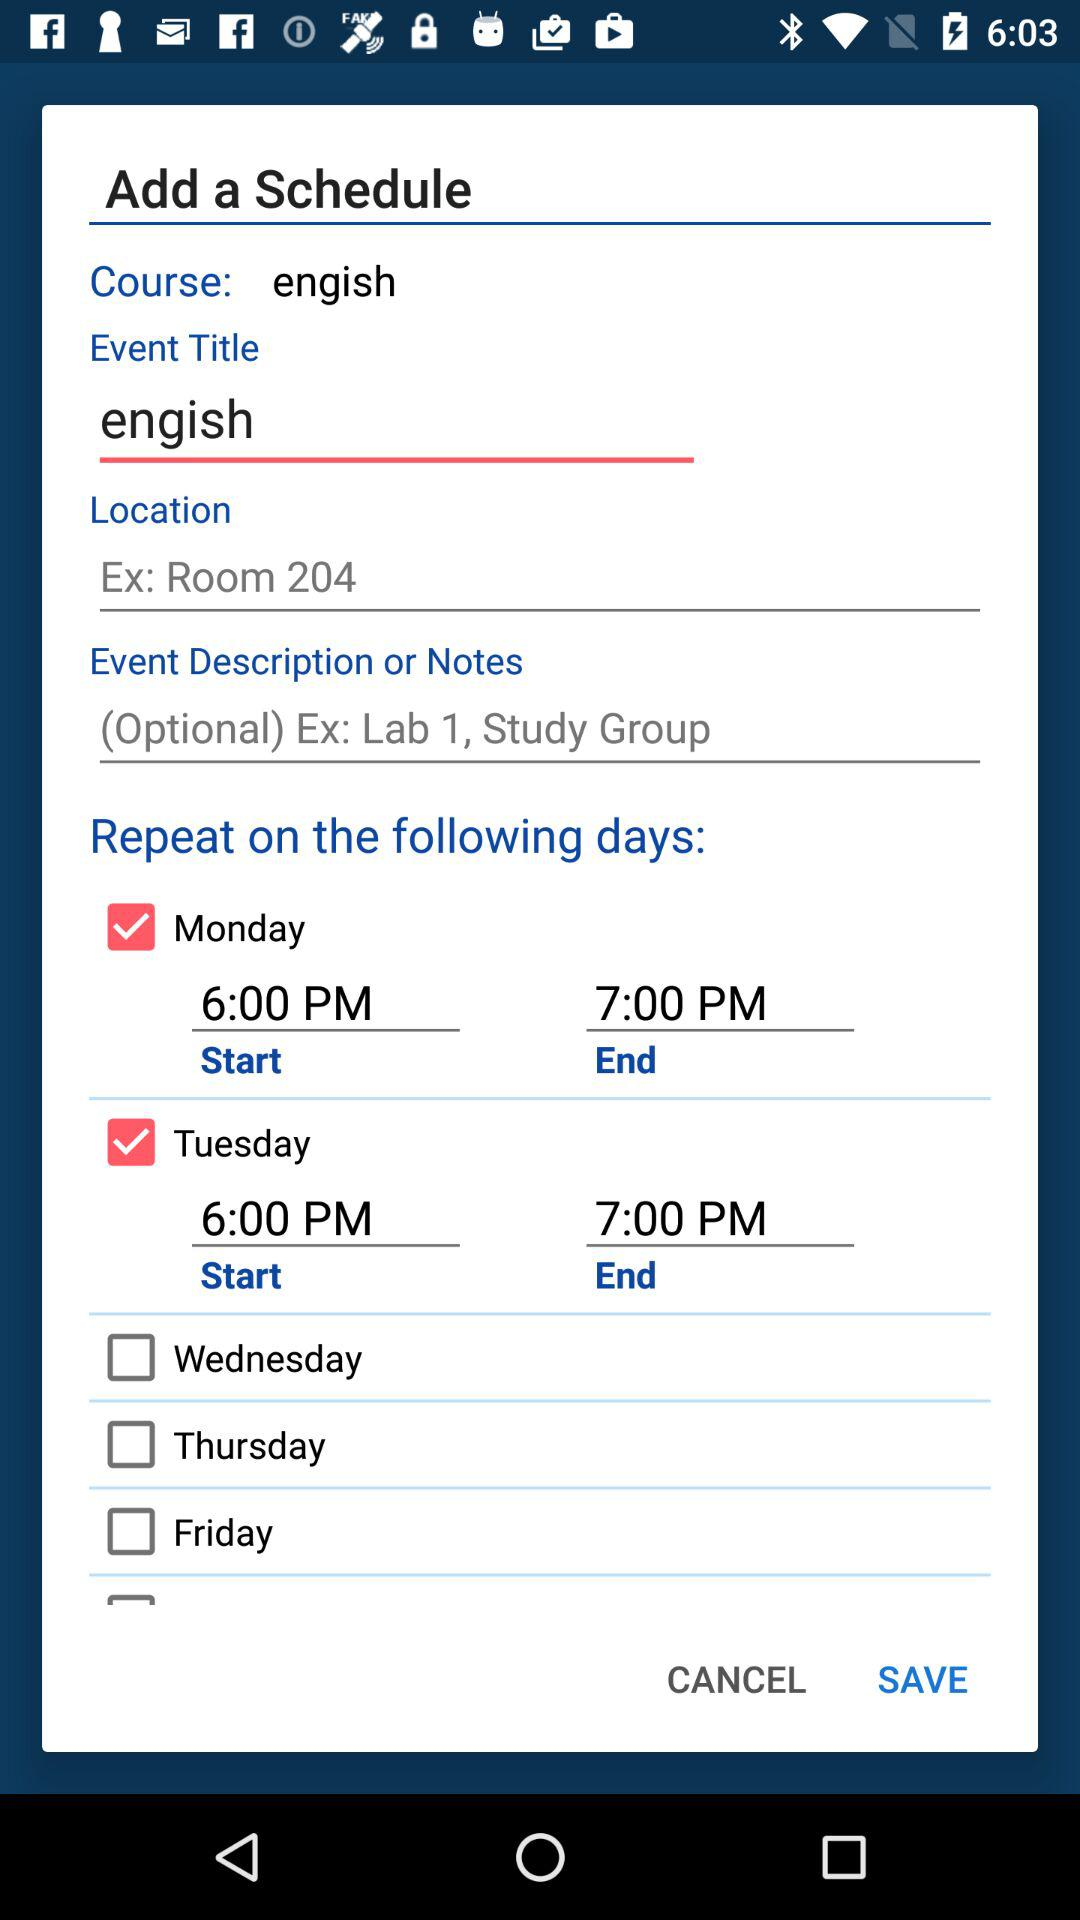What is the event title? The event title is "engish". 